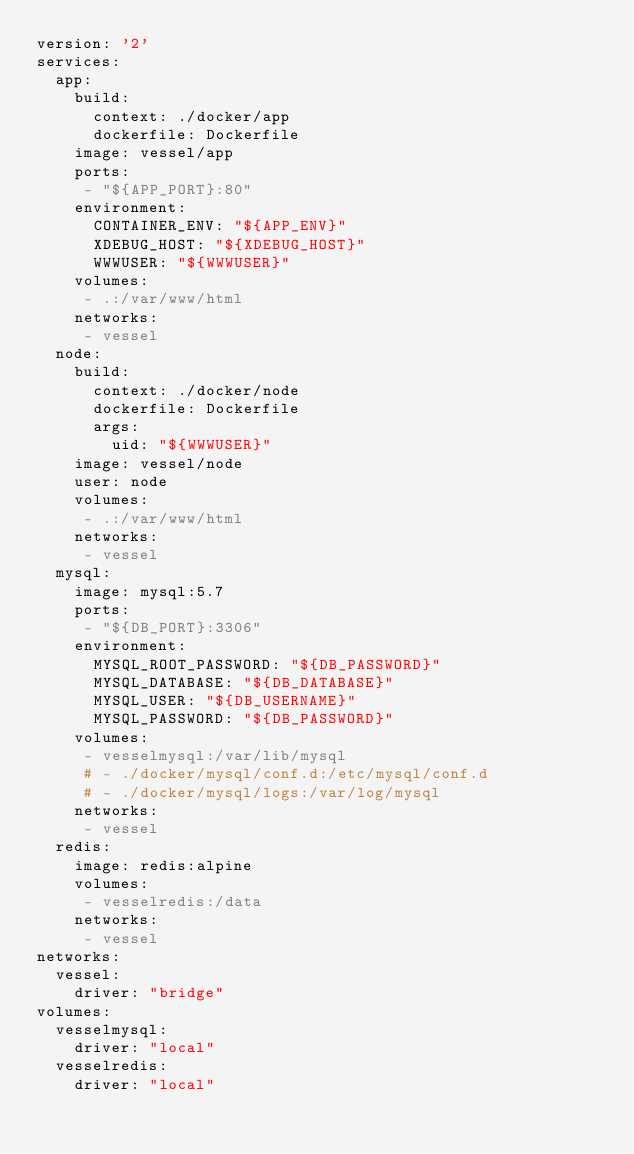<code> <loc_0><loc_0><loc_500><loc_500><_YAML_>version: '2'
services:
  app:
    build:
      context: ./docker/app
      dockerfile: Dockerfile
    image: vessel/app
    ports:
     - "${APP_PORT}:80"
    environment:
      CONTAINER_ENV: "${APP_ENV}"
      XDEBUG_HOST: "${XDEBUG_HOST}"
      WWWUSER: "${WWWUSER}"
    volumes:
     - .:/var/www/html
    networks:
     - vessel
  node:
    build:
      context: ./docker/node
      dockerfile: Dockerfile
      args:
        uid: "${WWWUSER}"
    image: vessel/node
    user: node
    volumes:
     - .:/var/www/html
    networks:
     - vessel
  mysql:
    image: mysql:5.7
    ports:
     - "${DB_PORT}:3306"
    environment:
      MYSQL_ROOT_PASSWORD: "${DB_PASSWORD}"
      MYSQL_DATABASE: "${DB_DATABASE}"
      MYSQL_USER: "${DB_USERNAME}"
      MYSQL_PASSWORD: "${DB_PASSWORD}"
    volumes:
     - vesselmysql:/var/lib/mysql
     # - ./docker/mysql/conf.d:/etc/mysql/conf.d
     # - ./docker/mysql/logs:/var/log/mysql
    networks:
     - vessel
  redis:
    image: redis:alpine
    volumes:
     - vesselredis:/data
    networks:
     - vessel
networks:
  vessel:
    driver: "bridge"
volumes:
  vesselmysql:
    driver: "local"
  vesselredis:
    driver: "local"
</code> 